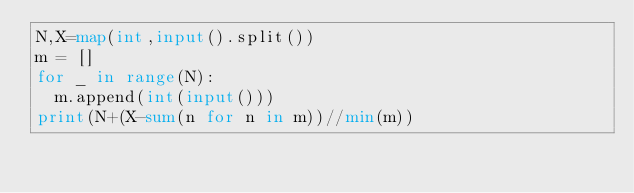Convert code to text. <code><loc_0><loc_0><loc_500><loc_500><_Python_>N,X=map(int,input().split())
m = []
for _ in range(N):
  m.append(int(input()))
print(N+(X-sum(n for n in m))//min(m))</code> 